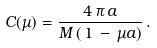Convert formula to latex. <formula><loc_0><loc_0><loc_500><loc_500>C ( \mu ) = \frac { 4 \, \pi \, a } { M \, ( \, 1 \, - \, \mu a ) } \, .</formula> 